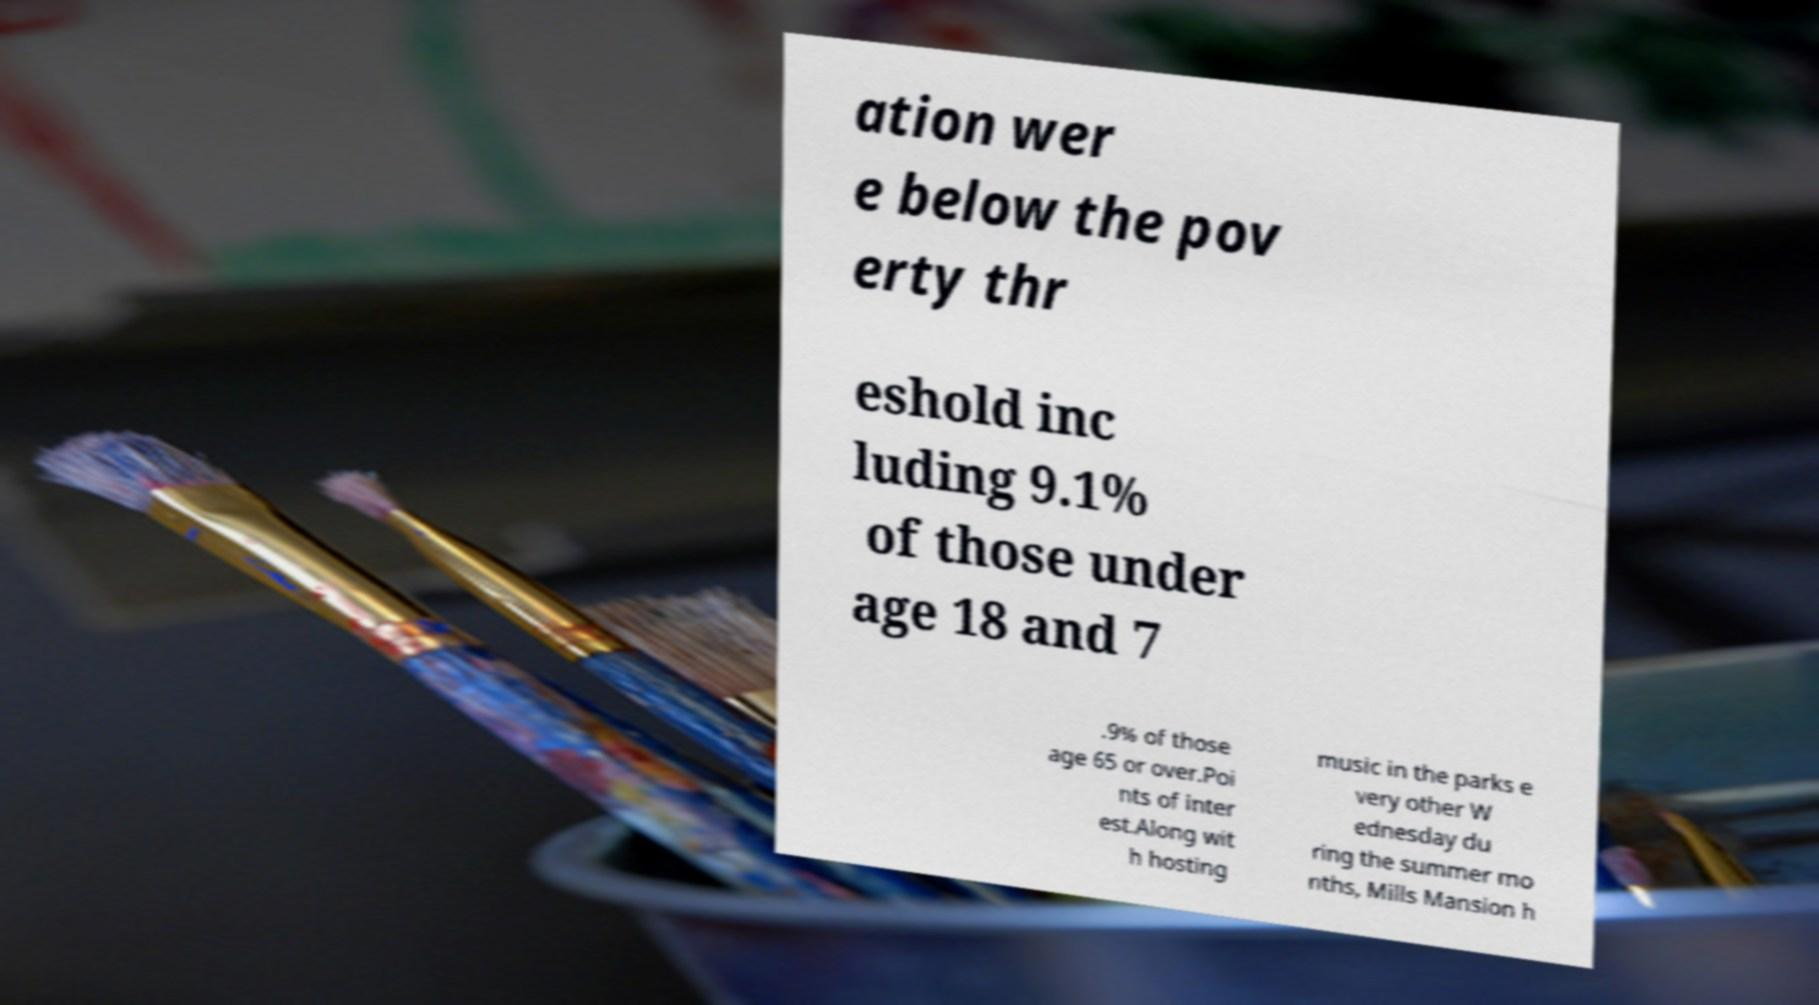Can you read and provide the text displayed in the image?This photo seems to have some interesting text. Can you extract and type it out for me? ation wer e below the pov erty thr eshold inc luding 9.1% of those under age 18 and 7 .9% of those age 65 or over.Poi nts of inter est.Along wit h hosting music in the parks e very other W ednesday du ring the summer mo nths, Mills Mansion h 